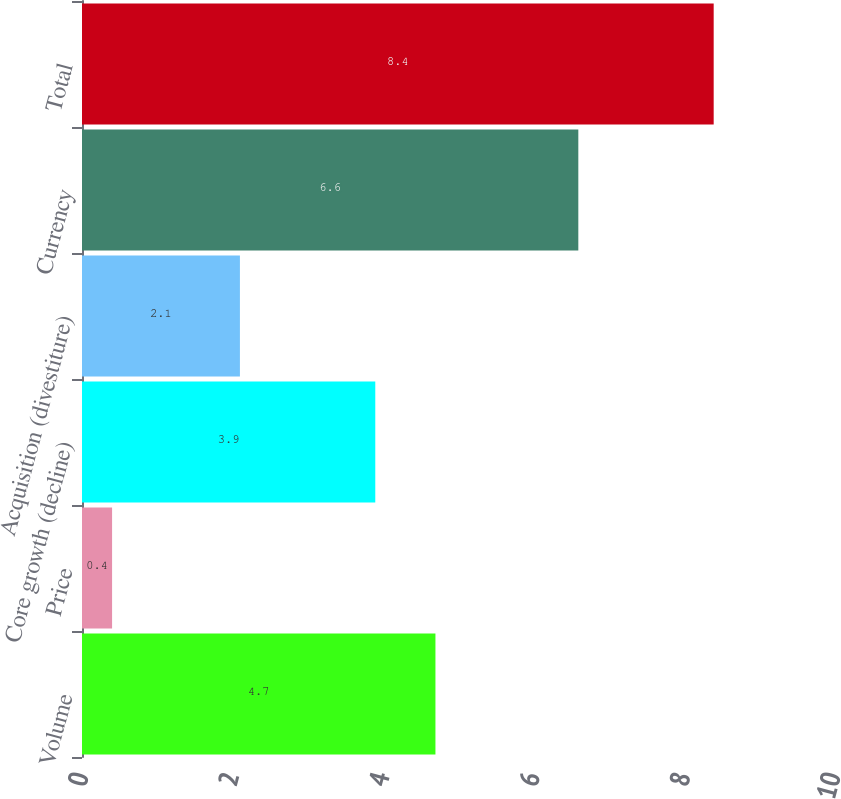<chart> <loc_0><loc_0><loc_500><loc_500><bar_chart><fcel>Volume<fcel>Price<fcel>Core growth (decline)<fcel>Acquisition (divestiture)<fcel>Currency<fcel>Total<nl><fcel>4.7<fcel>0.4<fcel>3.9<fcel>2.1<fcel>6.6<fcel>8.4<nl></chart> 